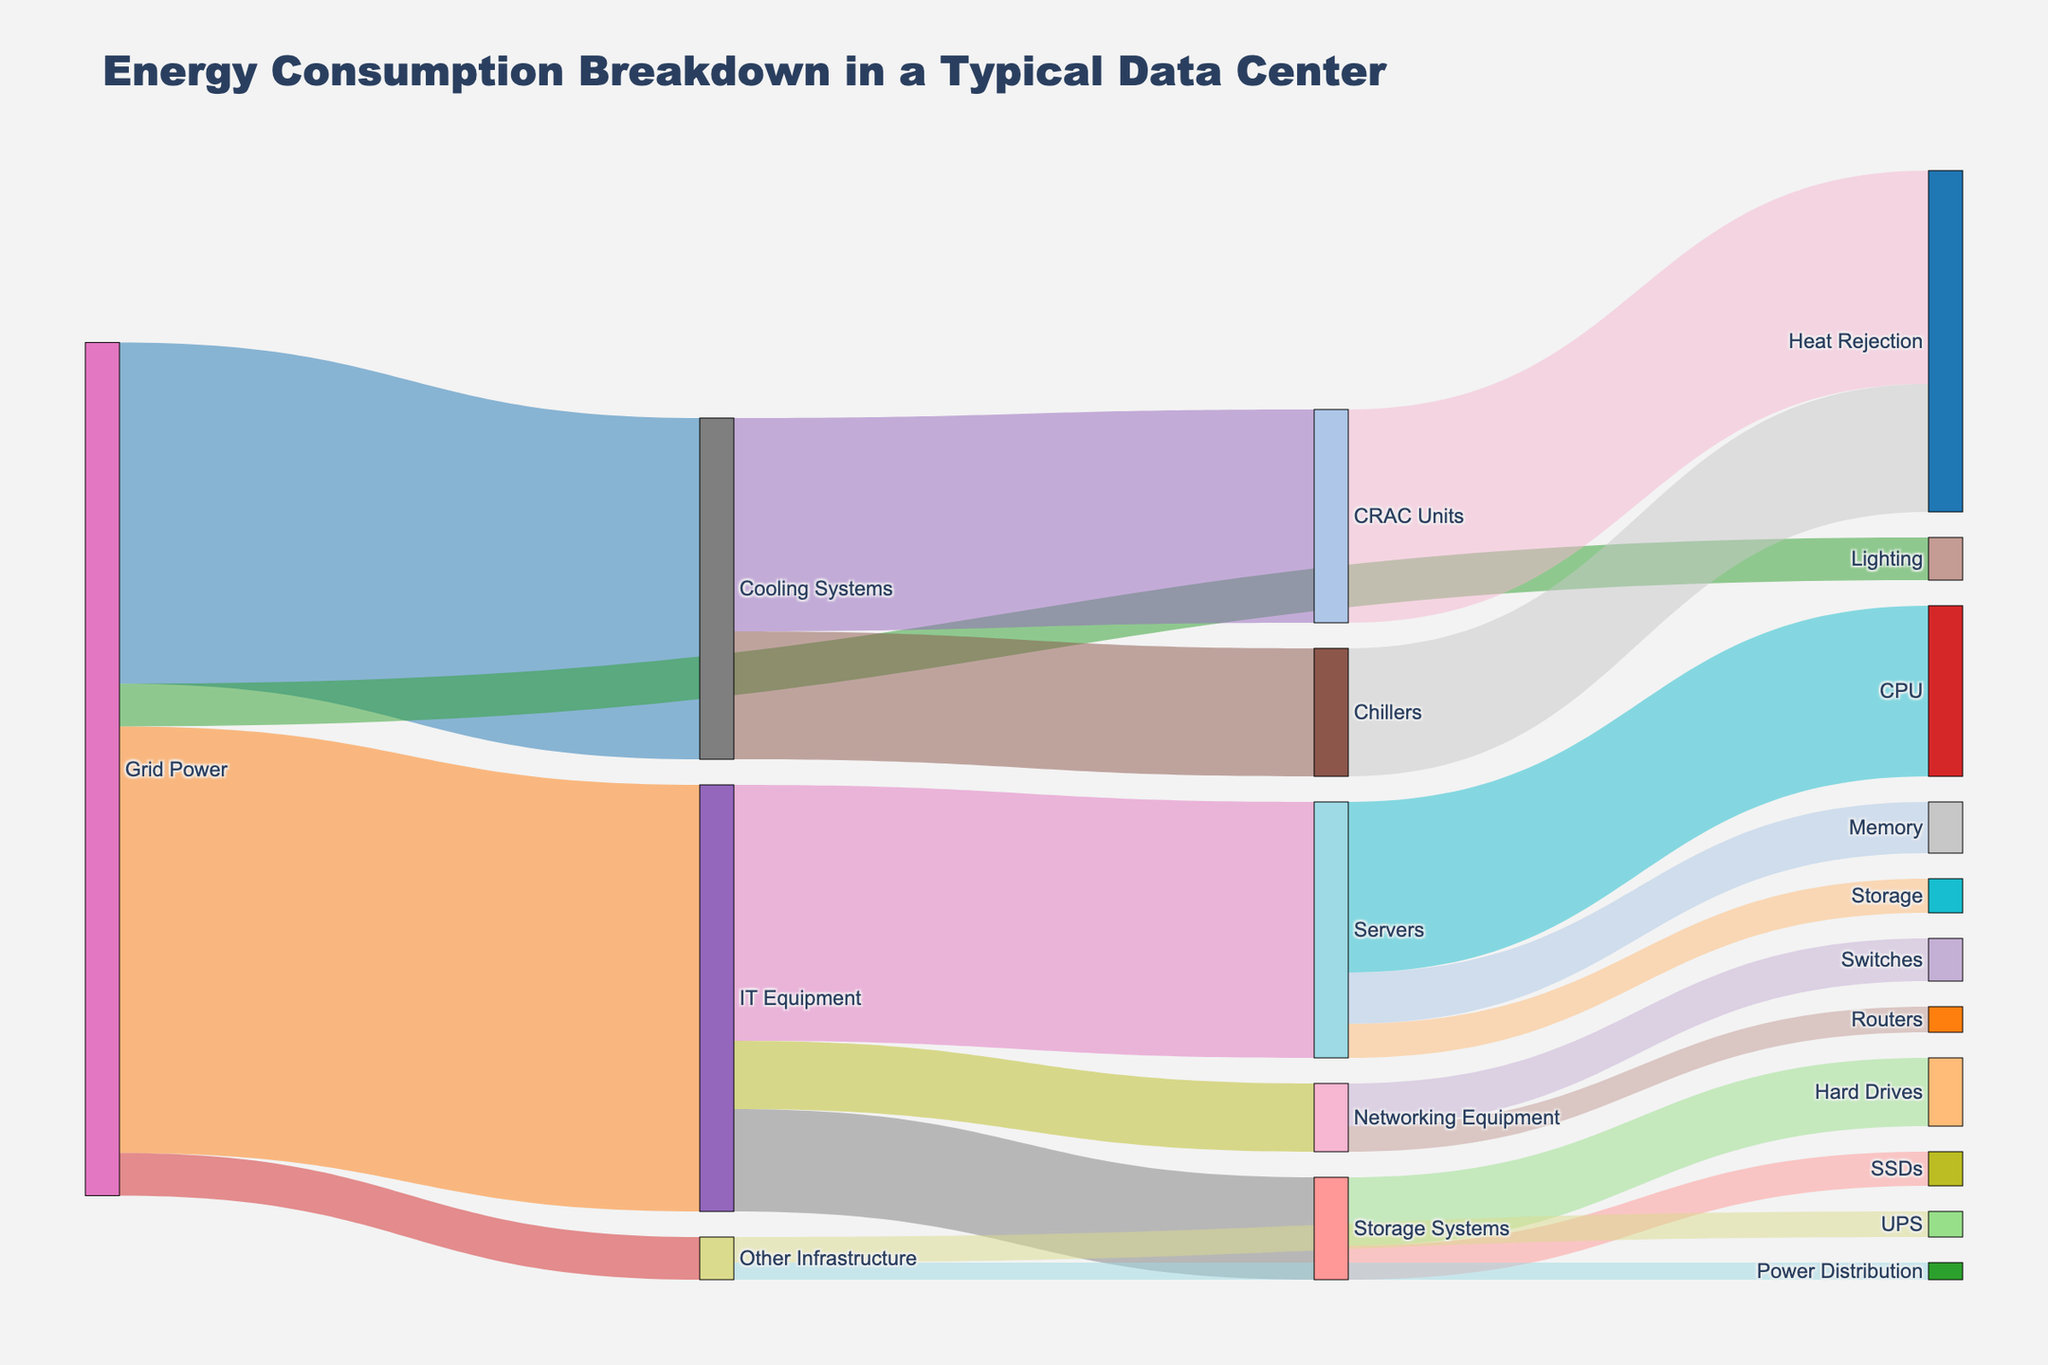What is the main source of energy in the data center? The Sankey diagram's title is "Energy Consumption Breakdown in a Typical Data Center," and the diagram shows that energy flows start from "Grid Power."
Answer: Grid Power How much energy is used by the IT Equipment? Adding up the values that flow from "Grid Power" to "IT Equipment" gives the total energy consumed by IT Equipment, which is indicated as 50.
Answer: 50 What is the total energy consumed by Cooling Systems and IT Equipment combined? The amount of energy consumed by Cooling Systems is 40, and by IT Equipment is 50. Adding these values together gives 40 + 50 = 90.
Answer: 90 Which component within IT Equipment uses the most energy? Within IT Equipment, the diagram shows that "Servers" use 30 units, "Storage Systems" use 12 units, and "Networking Equipment" use 8 units. The highest value among these is 30 by "Servers."
Answer: Servers Compare the energy use between the CPU and Memory components of the Servers. The diagram shows that within Servers, CPU uses 20 units, and Memory uses 6 units. CPU uses more energy than Memory.
Answer: CPU uses more What percentage of Grid Power is used for Lighting? Lighting uses 5 units out of the total Grid Power, which is 100 units. The percentage is (5/100) * 100 = 5%.
Answer: 5% Break down the energy usage within Storage Systems. Storage Systems consume 12 units in total. Hard Drives use 8 units, and SSDs use 4 units. Adding these up matches the total of 12.
Answer: Hard Drives: 8, SSDs: 4 What portion of energy consumed by Cooling Systems goes to CRAC Units? Cooling Systems use 40 units, and CRAC Units, being a part of Cooling Systems, use 25 units. The portion is (25/40) * 100 = 62.5%.
Answer: 62.5% What component under "Other Infrastructure" uses less energy? Under "Other Infrastructure," UPS uses 3 units, and Power Distribution uses 2 units. Power Distribution uses less energy.
Answer: Power Distribution How much energy is rejected as heat from the CRAC Units and Chillers combined? The diagram shows that CRAC Units reject 25 units of heat, and Chillers reject 15 units. Combined, this is 25 + 15 = 40 units.
Answer: 40 